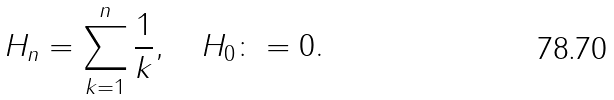<formula> <loc_0><loc_0><loc_500><loc_500>H _ { n } = \sum _ { k = 1 } ^ { n } \frac { 1 } { k } , \quad H _ { 0 } \colon = 0 .</formula> 